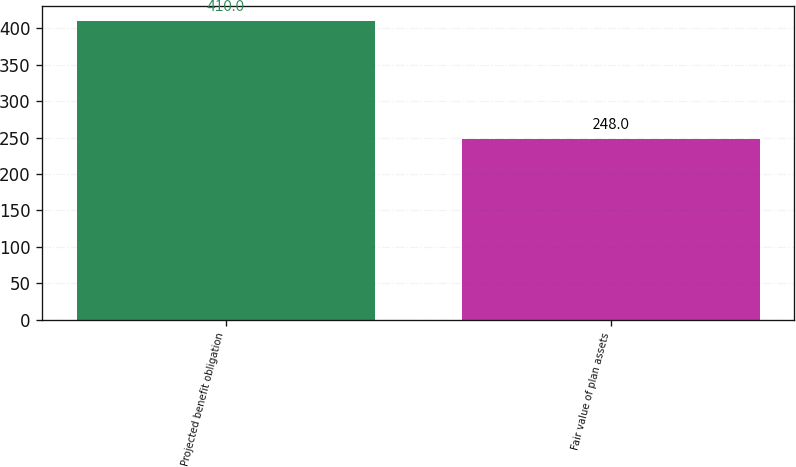<chart> <loc_0><loc_0><loc_500><loc_500><bar_chart><fcel>Projected benefit obligation<fcel>Fair value of plan assets<nl><fcel>410<fcel>248<nl></chart> 